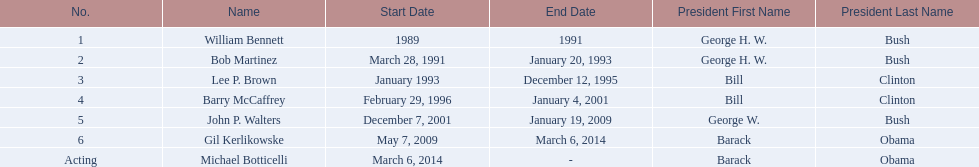When did john p. walters end his term? January 19, 2009. 